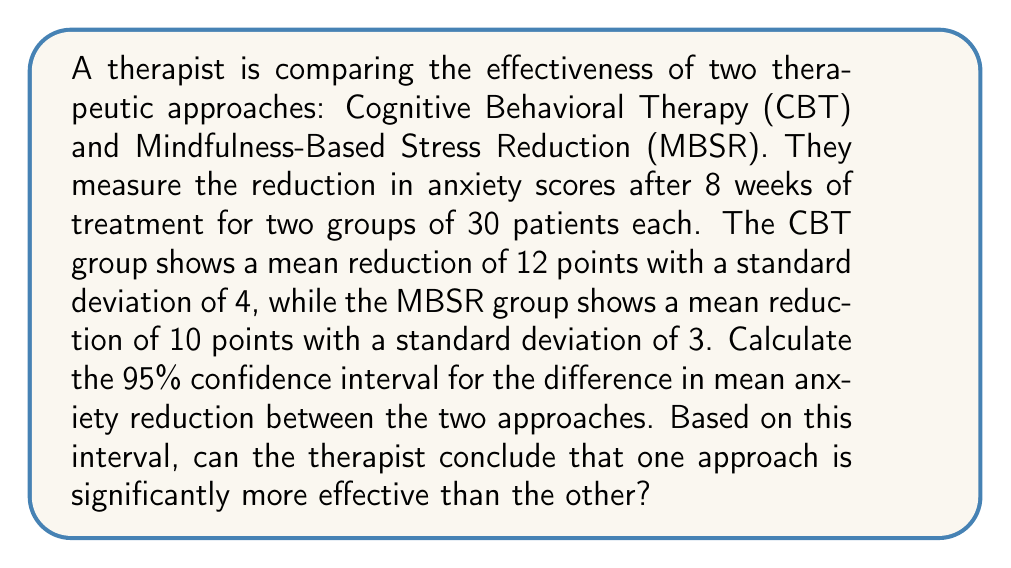Could you help me with this problem? To solve this problem, we'll follow these steps:

1) First, we need to calculate the standard error of the difference between means:

   $SE = \sqrt{\frac{s_1^2}{n_1} + \frac{s_2^2}{n_2}}$

   Where $s_1$ and $s_2$ are the standard deviations, and $n_1$ and $n_2$ are the sample sizes.

   $SE = \sqrt{\frac{4^2}{30} + \frac{3^2}{30}} = \sqrt{\frac{16}{30} + \frac{9}{30}} = \sqrt{\frac{25}{30}} = 0.913$

2) The difference in means is:
   $\bar{x}_1 - \bar{x}_2 = 12 - 10 = 2$

3) For a 95% confidence interval, we use a z-score of 1.96 (assuming large sample sizes).

4) The confidence interval is calculated as:
   $(\bar{x}_1 - \bar{x}_2) \pm (z \times SE)$

   Lower bound: $2 - (1.96 \times 0.913) = 0.21$
   Upper bound: $2 + (1.96 \times 0.913) = 3.79$

5) Therefore, the 95% confidence interval is (0.21, 3.79).

6) Interpretation: We can be 95% confident that the true difference in mean anxiety reduction between CBT and MBSR is between 0.21 and 3.79 points.

7) Since the confidence interval does not include 0, we can conclude that there is a statistically significant difference between the two approaches at the 5% level. CBT appears to be more effective as it results in a greater reduction in anxiety scores.
Answer: 95% CI: (0.21, 3.79). CBT is significantly more effective. 